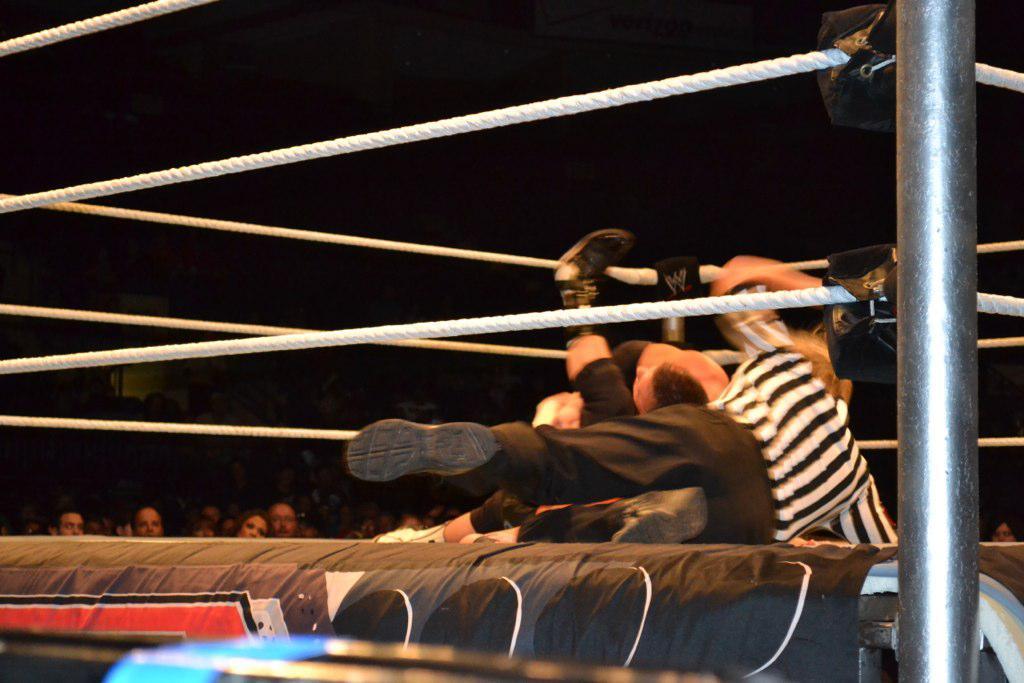Could you give a brief overview of what you see in this image? In this image we can see a kickboxing court and two persons are performing the show and one empire is there and some people are watching them. 